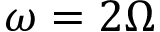Convert formula to latex. <formula><loc_0><loc_0><loc_500><loc_500>\omega = 2 \Omega</formula> 